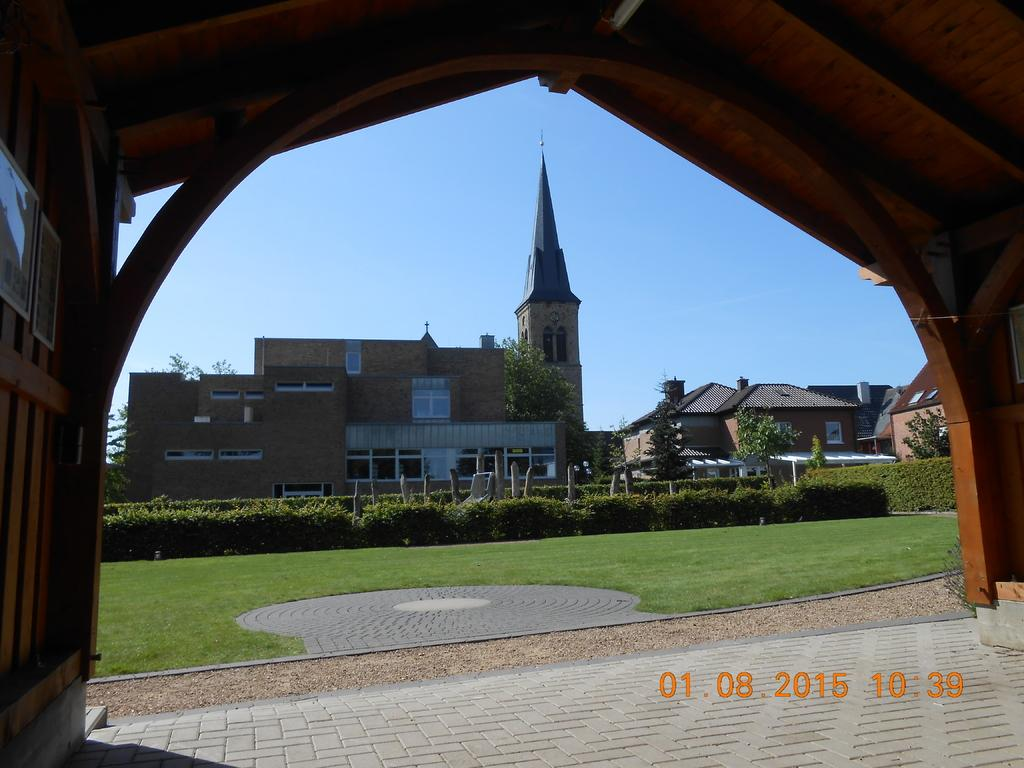What type of vegetation is present in the image? There is grass, plants, and trees in the image. What type of structures can be seen in the image? There are houses in the image. What is visible in the background of the image? The sky is visible in the background of the image. What type of soup is being served in the image? There is no soup present in the image. Who is the owner of the houses in the image? The image does not provide information about the ownership of the houses. 